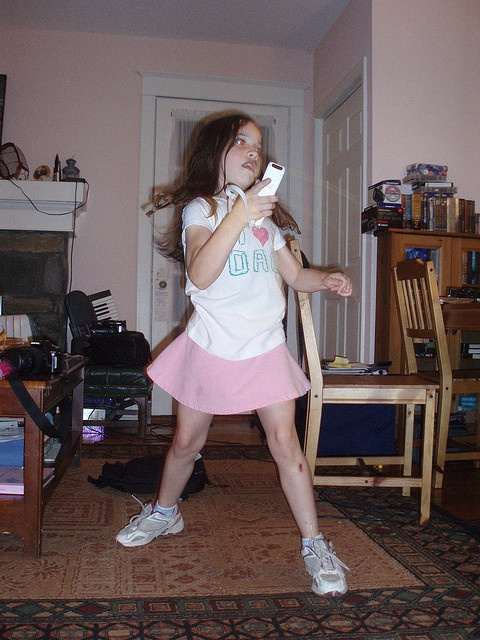Describe the objects in this image and their specific colors. I can see people in brown, darkgray, lavender, pink, and black tones, chair in brown, black, gray, and maroon tones, chair in brown, black, maroon, and gray tones, chair in brown, black, gray, and darkgray tones, and backpack in brown, black, maroon, and gray tones in this image. 